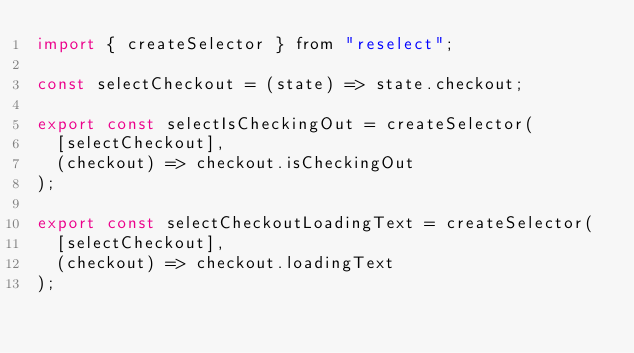<code> <loc_0><loc_0><loc_500><loc_500><_JavaScript_>import { createSelector } from "reselect";

const selectCheckout = (state) => state.checkout;

export const selectIsCheckingOut = createSelector(
  [selectCheckout],
  (checkout) => checkout.isCheckingOut
);

export const selectCheckoutLoadingText = createSelector(
  [selectCheckout],
  (checkout) => checkout.loadingText
);
</code> 